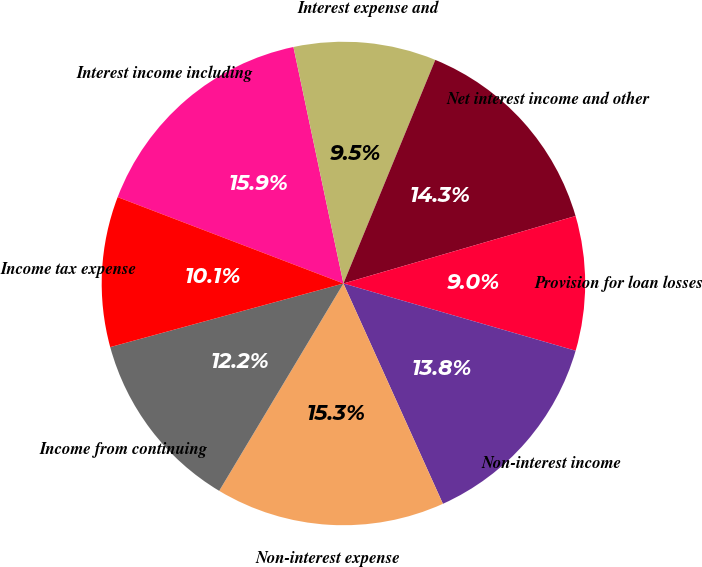Convert chart. <chart><loc_0><loc_0><loc_500><loc_500><pie_chart><fcel>Interest income including<fcel>Interest expense and<fcel>Net interest income and other<fcel>Provision for loan losses<fcel>Non-interest income<fcel>Non-interest expense<fcel>Income from continuing<fcel>Income tax expense<nl><fcel>15.87%<fcel>9.52%<fcel>14.29%<fcel>8.99%<fcel>13.76%<fcel>15.34%<fcel>12.17%<fcel>10.05%<nl></chart> 